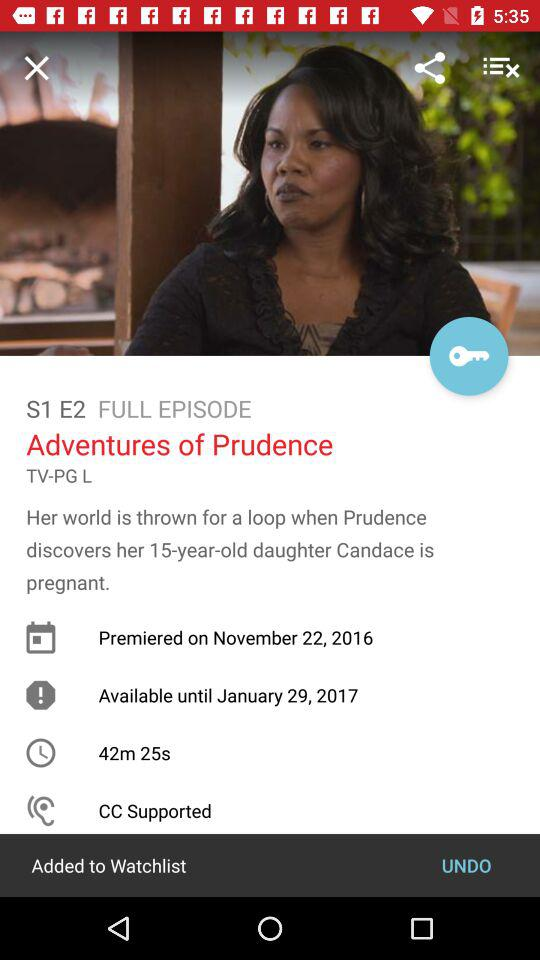What is the available date? The available date is January 29, 2017. 